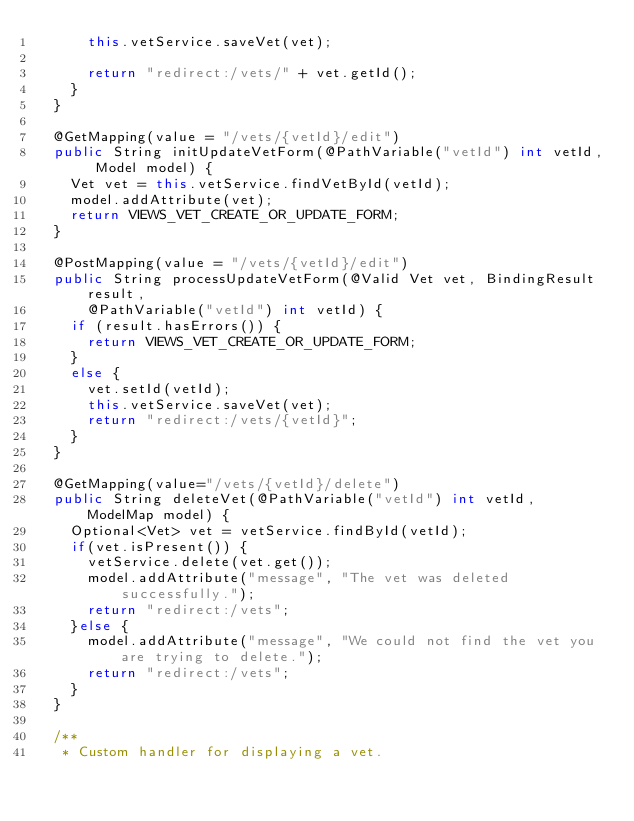Convert code to text. <code><loc_0><loc_0><loc_500><loc_500><_Java_>			this.vetService.saveVet(vet);
			
			return "redirect:/vets/" + vet.getId();
		}
	}
	
	@GetMapping(value = "/vets/{vetId}/edit")
	public String initUpdateVetForm(@PathVariable("vetId") int vetId, Model model) {
		Vet vet = this.vetService.findVetById(vetId);
		model.addAttribute(vet);
		return VIEWS_VET_CREATE_OR_UPDATE_FORM;
	}

	@PostMapping(value = "/vets/{vetId}/edit")
	public String processUpdateVetForm(@Valid Vet vet, BindingResult result,
			@PathVariable("vetId") int vetId) {
		if (result.hasErrors()) {
			return VIEWS_VET_CREATE_OR_UPDATE_FORM;
		}
		else {
			vet.setId(vetId);
			this.vetService.saveVet(vet);
			return "redirect:/vets/{vetId}";
		}
	}
	
	@GetMapping(value="/vets/{vetId}/delete")
	public String deleteVet(@PathVariable("vetId") int vetId, ModelMap model) {
		Optional<Vet> vet = vetService.findById(vetId);
		if(vet.isPresent()) {
			vetService.delete(vet.get());
			model.addAttribute("message", "The vet was deleted successfully.");
			return "redirect:/vets";
		}else {
			model.addAttribute("message", "We could not find the vet you are trying to delete.");
			return "redirect:/vets";
		}
	}
	
	/**
	 * Custom handler for displaying a vet.</code> 